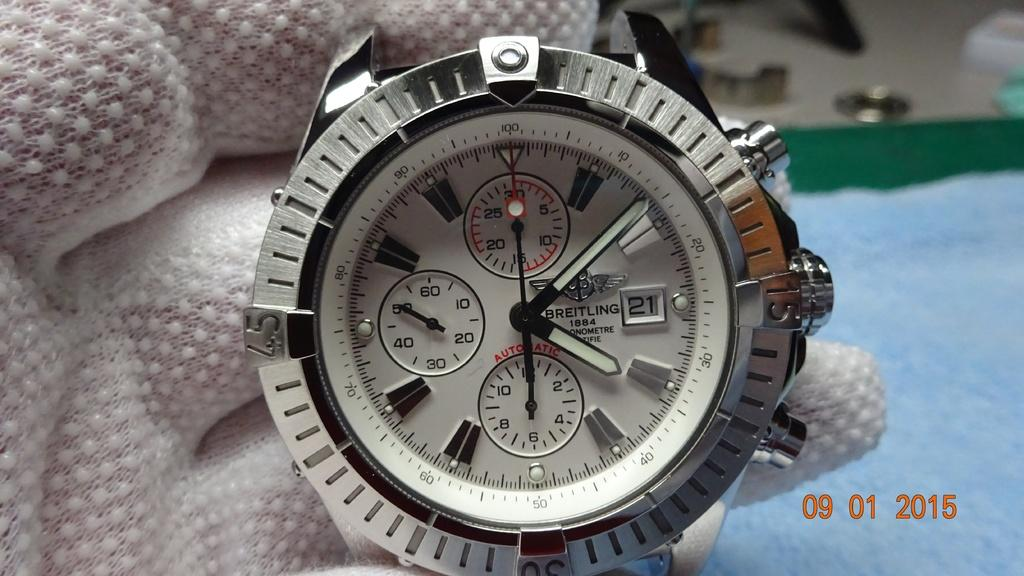<image>
Summarize the visual content of the image. A Breitling brand watch bears the year 1884 on the face. 